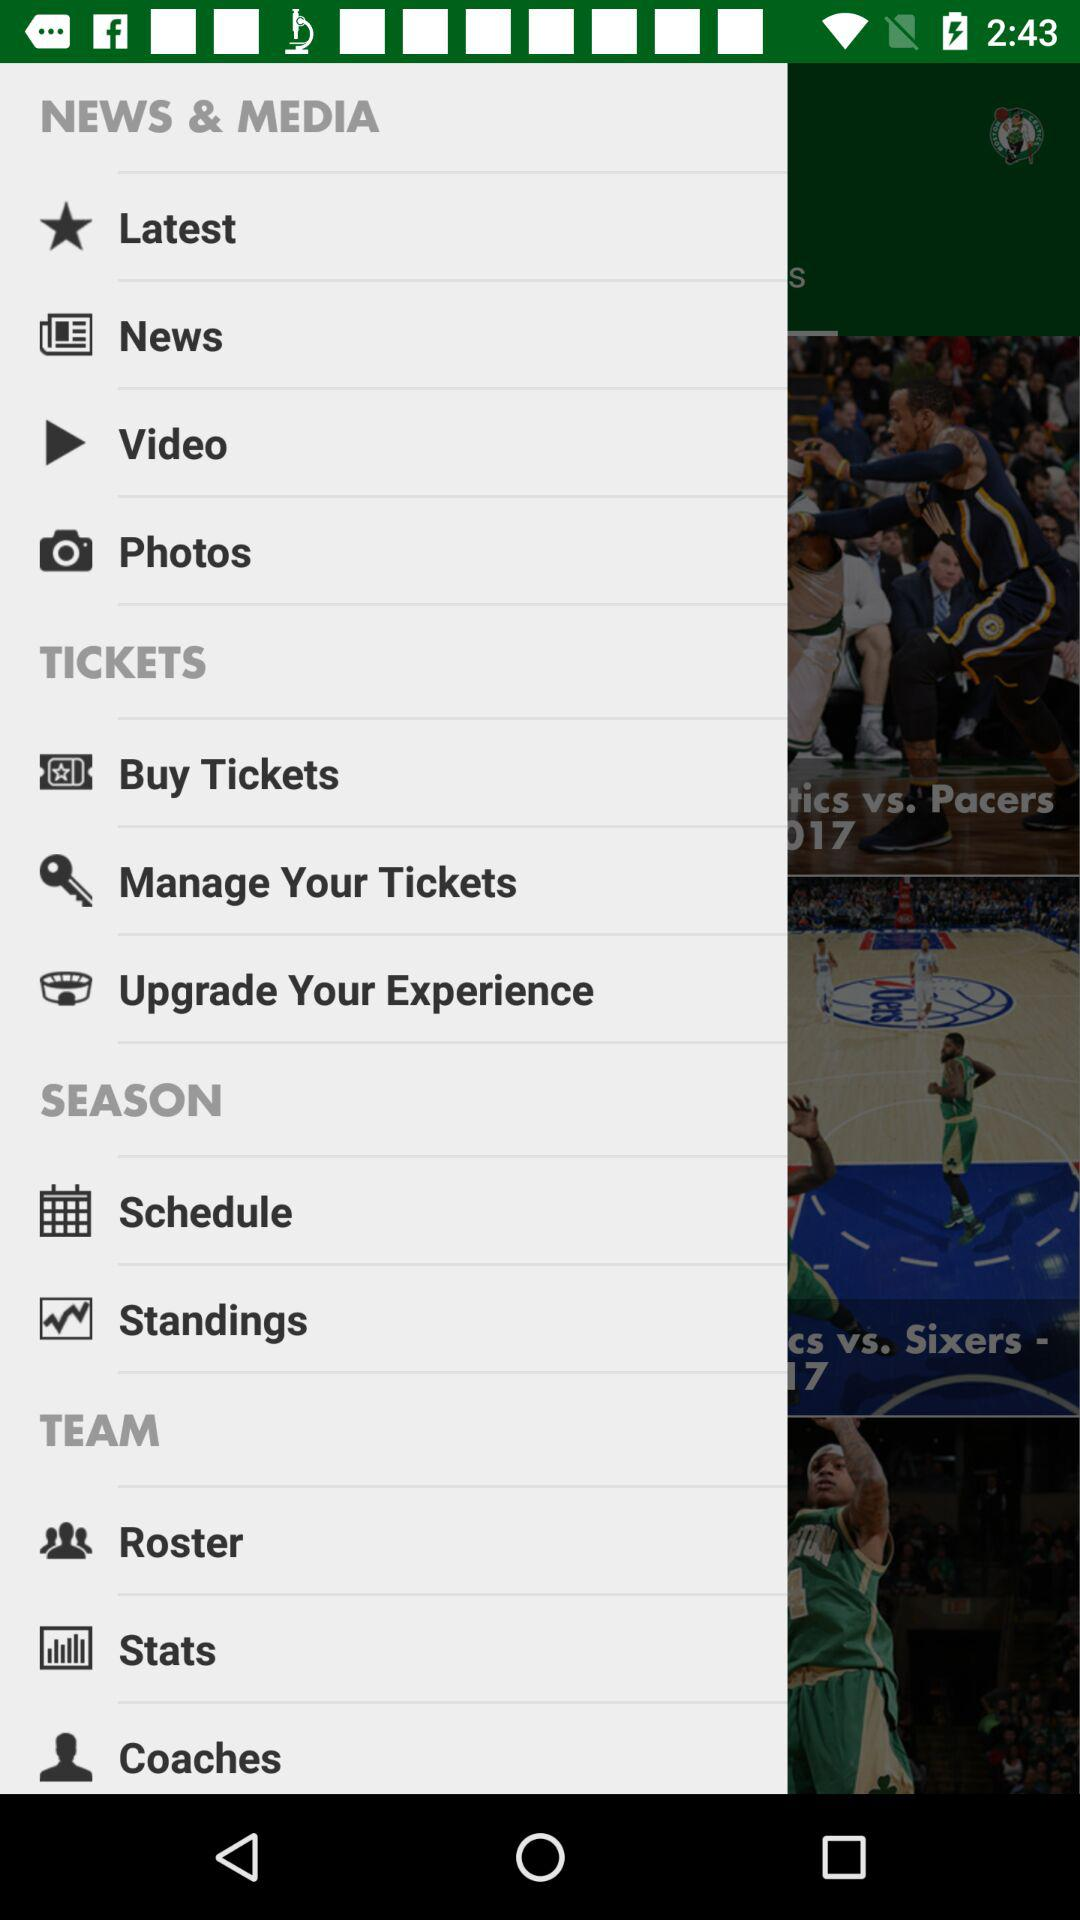How many items are in the tickets section?
Answer the question using a single word or phrase. 3 